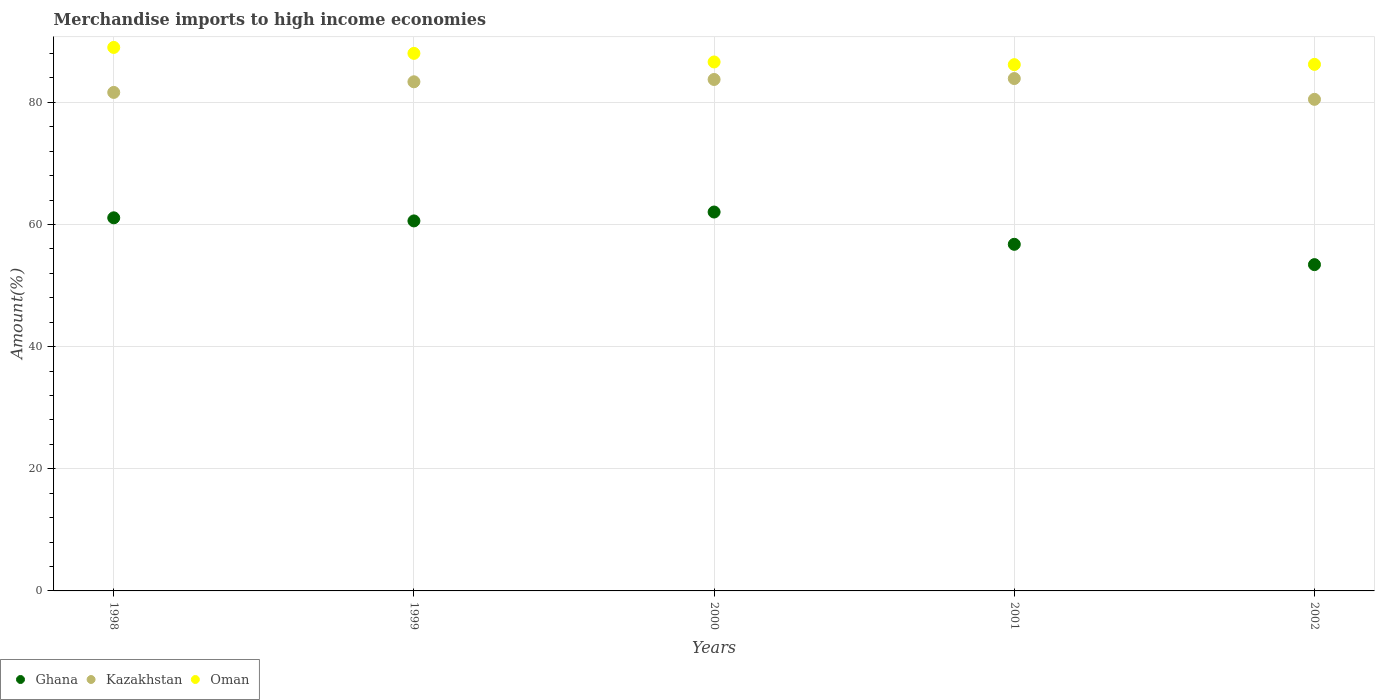Is the number of dotlines equal to the number of legend labels?
Your response must be concise. Yes. What is the percentage of amount earned from merchandise imports in Kazakhstan in 1999?
Offer a terse response. 83.37. Across all years, what is the maximum percentage of amount earned from merchandise imports in Oman?
Offer a very short reply. 89. Across all years, what is the minimum percentage of amount earned from merchandise imports in Ghana?
Give a very brief answer. 53.43. In which year was the percentage of amount earned from merchandise imports in Oman minimum?
Your response must be concise. 2001. What is the total percentage of amount earned from merchandise imports in Ghana in the graph?
Your answer should be very brief. 293.93. What is the difference between the percentage of amount earned from merchandise imports in Ghana in 2000 and that in 2001?
Offer a very short reply. 5.29. What is the difference between the percentage of amount earned from merchandise imports in Ghana in 2002 and the percentage of amount earned from merchandise imports in Kazakhstan in 1999?
Offer a terse response. -29.94. What is the average percentage of amount earned from merchandise imports in Oman per year?
Give a very brief answer. 87.21. In the year 2001, what is the difference between the percentage of amount earned from merchandise imports in Kazakhstan and percentage of amount earned from merchandise imports in Oman?
Give a very brief answer. -2.27. In how many years, is the percentage of amount earned from merchandise imports in Ghana greater than 44 %?
Provide a succinct answer. 5. What is the ratio of the percentage of amount earned from merchandise imports in Kazakhstan in 1999 to that in 2000?
Give a very brief answer. 1. Is the percentage of amount earned from merchandise imports in Ghana in 1998 less than that in 2001?
Give a very brief answer. No. Is the difference between the percentage of amount earned from merchandise imports in Kazakhstan in 1998 and 2002 greater than the difference between the percentage of amount earned from merchandise imports in Oman in 1998 and 2002?
Provide a succinct answer. No. What is the difference between the highest and the second highest percentage of amount earned from merchandise imports in Ghana?
Ensure brevity in your answer.  0.95. What is the difference between the highest and the lowest percentage of amount earned from merchandise imports in Ghana?
Offer a very short reply. 8.61. Is the sum of the percentage of amount earned from merchandise imports in Ghana in 1999 and 2002 greater than the maximum percentage of amount earned from merchandise imports in Oman across all years?
Ensure brevity in your answer.  Yes. Is it the case that in every year, the sum of the percentage of amount earned from merchandise imports in Oman and percentage of amount earned from merchandise imports in Ghana  is greater than the percentage of amount earned from merchandise imports in Kazakhstan?
Give a very brief answer. Yes. Is the percentage of amount earned from merchandise imports in Kazakhstan strictly greater than the percentage of amount earned from merchandise imports in Oman over the years?
Offer a terse response. No. How many dotlines are there?
Provide a short and direct response. 3. Are the values on the major ticks of Y-axis written in scientific E-notation?
Provide a short and direct response. No. How many legend labels are there?
Offer a very short reply. 3. How are the legend labels stacked?
Make the answer very short. Horizontal. What is the title of the graph?
Give a very brief answer. Merchandise imports to high income economies. Does "Morocco" appear as one of the legend labels in the graph?
Give a very brief answer. No. What is the label or title of the X-axis?
Your answer should be very brief. Years. What is the label or title of the Y-axis?
Ensure brevity in your answer.  Amount(%). What is the Amount(%) in Ghana in 1998?
Provide a succinct answer. 61.1. What is the Amount(%) of Kazakhstan in 1998?
Ensure brevity in your answer.  81.63. What is the Amount(%) of Oman in 1998?
Provide a succinct answer. 89. What is the Amount(%) of Ghana in 1999?
Provide a short and direct response. 60.59. What is the Amount(%) of Kazakhstan in 1999?
Keep it short and to the point. 83.37. What is the Amount(%) of Oman in 1999?
Provide a succinct answer. 88.03. What is the Amount(%) of Ghana in 2000?
Make the answer very short. 62.05. What is the Amount(%) of Kazakhstan in 2000?
Your response must be concise. 83.75. What is the Amount(%) of Oman in 2000?
Provide a short and direct response. 86.62. What is the Amount(%) of Ghana in 2001?
Provide a short and direct response. 56.76. What is the Amount(%) in Kazakhstan in 2001?
Make the answer very short. 83.91. What is the Amount(%) of Oman in 2001?
Keep it short and to the point. 86.18. What is the Amount(%) of Ghana in 2002?
Ensure brevity in your answer.  53.43. What is the Amount(%) of Kazakhstan in 2002?
Provide a short and direct response. 80.5. What is the Amount(%) in Oman in 2002?
Make the answer very short. 86.23. Across all years, what is the maximum Amount(%) in Ghana?
Ensure brevity in your answer.  62.05. Across all years, what is the maximum Amount(%) in Kazakhstan?
Offer a terse response. 83.91. Across all years, what is the maximum Amount(%) of Oman?
Give a very brief answer. 89. Across all years, what is the minimum Amount(%) in Ghana?
Your answer should be very brief. 53.43. Across all years, what is the minimum Amount(%) in Kazakhstan?
Provide a succinct answer. 80.5. Across all years, what is the minimum Amount(%) of Oman?
Ensure brevity in your answer.  86.18. What is the total Amount(%) of Ghana in the graph?
Keep it short and to the point. 293.93. What is the total Amount(%) in Kazakhstan in the graph?
Keep it short and to the point. 413.17. What is the total Amount(%) of Oman in the graph?
Offer a terse response. 436.06. What is the difference between the Amount(%) of Ghana in 1998 and that in 1999?
Offer a terse response. 0.51. What is the difference between the Amount(%) in Kazakhstan in 1998 and that in 1999?
Provide a succinct answer. -1.74. What is the difference between the Amount(%) of Oman in 1998 and that in 1999?
Provide a succinct answer. 0.97. What is the difference between the Amount(%) in Ghana in 1998 and that in 2000?
Your response must be concise. -0.95. What is the difference between the Amount(%) of Kazakhstan in 1998 and that in 2000?
Provide a succinct answer. -2.12. What is the difference between the Amount(%) of Oman in 1998 and that in 2000?
Your response must be concise. 2.38. What is the difference between the Amount(%) of Ghana in 1998 and that in 2001?
Offer a very short reply. 4.34. What is the difference between the Amount(%) of Kazakhstan in 1998 and that in 2001?
Your answer should be very brief. -2.27. What is the difference between the Amount(%) of Oman in 1998 and that in 2001?
Your answer should be compact. 2.82. What is the difference between the Amount(%) of Ghana in 1998 and that in 2002?
Ensure brevity in your answer.  7.67. What is the difference between the Amount(%) of Kazakhstan in 1998 and that in 2002?
Offer a very short reply. 1.13. What is the difference between the Amount(%) in Oman in 1998 and that in 2002?
Your response must be concise. 2.77. What is the difference between the Amount(%) in Ghana in 1999 and that in 2000?
Make the answer very short. -1.46. What is the difference between the Amount(%) in Kazakhstan in 1999 and that in 2000?
Provide a succinct answer. -0.38. What is the difference between the Amount(%) of Oman in 1999 and that in 2000?
Offer a very short reply. 1.41. What is the difference between the Amount(%) in Ghana in 1999 and that in 2001?
Your answer should be very brief. 3.83. What is the difference between the Amount(%) in Kazakhstan in 1999 and that in 2001?
Offer a very short reply. -0.53. What is the difference between the Amount(%) in Oman in 1999 and that in 2001?
Give a very brief answer. 1.85. What is the difference between the Amount(%) of Ghana in 1999 and that in 2002?
Keep it short and to the point. 7.16. What is the difference between the Amount(%) in Kazakhstan in 1999 and that in 2002?
Offer a terse response. 2.87. What is the difference between the Amount(%) of Oman in 1999 and that in 2002?
Your response must be concise. 1.8. What is the difference between the Amount(%) of Ghana in 2000 and that in 2001?
Provide a short and direct response. 5.29. What is the difference between the Amount(%) in Kazakhstan in 2000 and that in 2001?
Give a very brief answer. -0.15. What is the difference between the Amount(%) in Oman in 2000 and that in 2001?
Your answer should be very brief. 0.44. What is the difference between the Amount(%) in Ghana in 2000 and that in 2002?
Make the answer very short. 8.61. What is the difference between the Amount(%) in Kazakhstan in 2000 and that in 2002?
Provide a succinct answer. 3.25. What is the difference between the Amount(%) in Oman in 2000 and that in 2002?
Your answer should be very brief. 0.39. What is the difference between the Amount(%) of Ghana in 2001 and that in 2002?
Keep it short and to the point. 3.33. What is the difference between the Amount(%) of Kazakhstan in 2001 and that in 2002?
Your response must be concise. 3.41. What is the difference between the Amount(%) of Oman in 2001 and that in 2002?
Offer a very short reply. -0.05. What is the difference between the Amount(%) of Ghana in 1998 and the Amount(%) of Kazakhstan in 1999?
Provide a succinct answer. -22.28. What is the difference between the Amount(%) of Ghana in 1998 and the Amount(%) of Oman in 1999?
Provide a succinct answer. -26.93. What is the difference between the Amount(%) in Kazakhstan in 1998 and the Amount(%) in Oman in 1999?
Offer a terse response. -6.39. What is the difference between the Amount(%) in Ghana in 1998 and the Amount(%) in Kazakhstan in 2000?
Ensure brevity in your answer.  -22.66. What is the difference between the Amount(%) of Ghana in 1998 and the Amount(%) of Oman in 2000?
Provide a short and direct response. -25.52. What is the difference between the Amount(%) of Kazakhstan in 1998 and the Amount(%) of Oman in 2000?
Make the answer very short. -4.99. What is the difference between the Amount(%) in Ghana in 1998 and the Amount(%) in Kazakhstan in 2001?
Offer a terse response. -22.81. What is the difference between the Amount(%) of Ghana in 1998 and the Amount(%) of Oman in 2001?
Offer a very short reply. -25.08. What is the difference between the Amount(%) in Kazakhstan in 1998 and the Amount(%) in Oman in 2001?
Keep it short and to the point. -4.55. What is the difference between the Amount(%) in Ghana in 1998 and the Amount(%) in Kazakhstan in 2002?
Your answer should be compact. -19.4. What is the difference between the Amount(%) of Ghana in 1998 and the Amount(%) of Oman in 2002?
Your answer should be very brief. -25.13. What is the difference between the Amount(%) of Kazakhstan in 1998 and the Amount(%) of Oman in 2002?
Offer a terse response. -4.59. What is the difference between the Amount(%) of Ghana in 1999 and the Amount(%) of Kazakhstan in 2000?
Provide a short and direct response. -23.16. What is the difference between the Amount(%) in Ghana in 1999 and the Amount(%) in Oman in 2000?
Give a very brief answer. -26.03. What is the difference between the Amount(%) of Kazakhstan in 1999 and the Amount(%) of Oman in 2000?
Offer a terse response. -3.25. What is the difference between the Amount(%) in Ghana in 1999 and the Amount(%) in Kazakhstan in 2001?
Ensure brevity in your answer.  -23.31. What is the difference between the Amount(%) of Ghana in 1999 and the Amount(%) of Oman in 2001?
Offer a terse response. -25.59. What is the difference between the Amount(%) of Kazakhstan in 1999 and the Amount(%) of Oman in 2001?
Your response must be concise. -2.81. What is the difference between the Amount(%) in Ghana in 1999 and the Amount(%) in Kazakhstan in 2002?
Ensure brevity in your answer.  -19.91. What is the difference between the Amount(%) in Ghana in 1999 and the Amount(%) in Oman in 2002?
Your answer should be compact. -25.64. What is the difference between the Amount(%) in Kazakhstan in 1999 and the Amount(%) in Oman in 2002?
Your answer should be compact. -2.85. What is the difference between the Amount(%) in Ghana in 2000 and the Amount(%) in Kazakhstan in 2001?
Offer a very short reply. -21.86. What is the difference between the Amount(%) in Ghana in 2000 and the Amount(%) in Oman in 2001?
Give a very brief answer. -24.13. What is the difference between the Amount(%) of Kazakhstan in 2000 and the Amount(%) of Oman in 2001?
Provide a succinct answer. -2.43. What is the difference between the Amount(%) of Ghana in 2000 and the Amount(%) of Kazakhstan in 2002?
Provide a short and direct response. -18.45. What is the difference between the Amount(%) of Ghana in 2000 and the Amount(%) of Oman in 2002?
Make the answer very short. -24.18. What is the difference between the Amount(%) of Kazakhstan in 2000 and the Amount(%) of Oman in 2002?
Your answer should be very brief. -2.47. What is the difference between the Amount(%) in Ghana in 2001 and the Amount(%) in Kazakhstan in 2002?
Make the answer very short. -23.74. What is the difference between the Amount(%) of Ghana in 2001 and the Amount(%) of Oman in 2002?
Provide a short and direct response. -29.47. What is the difference between the Amount(%) in Kazakhstan in 2001 and the Amount(%) in Oman in 2002?
Your answer should be compact. -2.32. What is the average Amount(%) of Ghana per year?
Your answer should be compact. 58.79. What is the average Amount(%) of Kazakhstan per year?
Your answer should be compact. 82.63. What is the average Amount(%) of Oman per year?
Keep it short and to the point. 87.21. In the year 1998, what is the difference between the Amount(%) in Ghana and Amount(%) in Kazakhstan?
Your answer should be compact. -20.54. In the year 1998, what is the difference between the Amount(%) in Ghana and Amount(%) in Oman?
Ensure brevity in your answer.  -27.9. In the year 1998, what is the difference between the Amount(%) in Kazakhstan and Amount(%) in Oman?
Keep it short and to the point. -7.37. In the year 1999, what is the difference between the Amount(%) of Ghana and Amount(%) of Kazakhstan?
Your answer should be very brief. -22.78. In the year 1999, what is the difference between the Amount(%) of Ghana and Amount(%) of Oman?
Your response must be concise. -27.44. In the year 1999, what is the difference between the Amount(%) in Kazakhstan and Amount(%) in Oman?
Your response must be concise. -4.65. In the year 2000, what is the difference between the Amount(%) in Ghana and Amount(%) in Kazakhstan?
Keep it short and to the point. -21.71. In the year 2000, what is the difference between the Amount(%) in Ghana and Amount(%) in Oman?
Provide a succinct answer. -24.57. In the year 2000, what is the difference between the Amount(%) of Kazakhstan and Amount(%) of Oman?
Provide a short and direct response. -2.87. In the year 2001, what is the difference between the Amount(%) in Ghana and Amount(%) in Kazakhstan?
Make the answer very short. -27.14. In the year 2001, what is the difference between the Amount(%) in Ghana and Amount(%) in Oman?
Your answer should be compact. -29.42. In the year 2001, what is the difference between the Amount(%) of Kazakhstan and Amount(%) of Oman?
Your response must be concise. -2.27. In the year 2002, what is the difference between the Amount(%) in Ghana and Amount(%) in Kazakhstan?
Offer a terse response. -27.07. In the year 2002, what is the difference between the Amount(%) of Ghana and Amount(%) of Oman?
Provide a short and direct response. -32.79. In the year 2002, what is the difference between the Amount(%) of Kazakhstan and Amount(%) of Oman?
Offer a terse response. -5.73. What is the ratio of the Amount(%) of Ghana in 1998 to that in 1999?
Provide a short and direct response. 1.01. What is the ratio of the Amount(%) in Kazakhstan in 1998 to that in 1999?
Offer a very short reply. 0.98. What is the ratio of the Amount(%) in Oman in 1998 to that in 1999?
Your answer should be compact. 1.01. What is the ratio of the Amount(%) of Ghana in 1998 to that in 2000?
Your answer should be very brief. 0.98. What is the ratio of the Amount(%) of Kazakhstan in 1998 to that in 2000?
Your answer should be very brief. 0.97. What is the ratio of the Amount(%) in Oman in 1998 to that in 2000?
Your response must be concise. 1.03. What is the ratio of the Amount(%) of Ghana in 1998 to that in 2001?
Provide a succinct answer. 1.08. What is the ratio of the Amount(%) of Kazakhstan in 1998 to that in 2001?
Offer a very short reply. 0.97. What is the ratio of the Amount(%) of Oman in 1998 to that in 2001?
Your answer should be compact. 1.03. What is the ratio of the Amount(%) of Ghana in 1998 to that in 2002?
Offer a terse response. 1.14. What is the ratio of the Amount(%) in Kazakhstan in 1998 to that in 2002?
Your response must be concise. 1.01. What is the ratio of the Amount(%) in Oman in 1998 to that in 2002?
Offer a terse response. 1.03. What is the ratio of the Amount(%) of Ghana in 1999 to that in 2000?
Ensure brevity in your answer.  0.98. What is the ratio of the Amount(%) in Oman in 1999 to that in 2000?
Keep it short and to the point. 1.02. What is the ratio of the Amount(%) in Ghana in 1999 to that in 2001?
Make the answer very short. 1.07. What is the ratio of the Amount(%) in Kazakhstan in 1999 to that in 2001?
Provide a short and direct response. 0.99. What is the ratio of the Amount(%) in Oman in 1999 to that in 2001?
Provide a short and direct response. 1.02. What is the ratio of the Amount(%) in Ghana in 1999 to that in 2002?
Make the answer very short. 1.13. What is the ratio of the Amount(%) in Kazakhstan in 1999 to that in 2002?
Offer a terse response. 1.04. What is the ratio of the Amount(%) in Oman in 1999 to that in 2002?
Give a very brief answer. 1.02. What is the ratio of the Amount(%) in Ghana in 2000 to that in 2001?
Your response must be concise. 1.09. What is the ratio of the Amount(%) of Oman in 2000 to that in 2001?
Keep it short and to the point. 1.01. What is the ratio of the Amount(%) of Ghana in 2000 to that in 2002?
Make the answer very short. 1.16. What is the ratio of the Amount(%) of Kazakhstan in 2000 to that in 2002?
Your answer should be compact. 1.04. What is the ratio of the Amount(%) in Ghana in 2001 to that in 2002?
Provide a succinct answer. 1.06. What is the ratio of the Amount(%) of Kazakhstan in 2001 to that in 2002?
Provide a short and direct response. 1.04. What is the ratio of the Amount(%) of Oman in 2001 to that in 2002?
Provide a short and direct response. 1. What is the difference between the highest and the second highest Amount(%) of Ghana?
Keep it short and to the point. 0.95. What is the difference between the highest and the second highest Amount(%) of Kazakhstan?
Your answer should be compact. 0.15. What is the difference between the highest and the second highest Amount(%) in Oman?
Ensure brevity in your answer.  0.97. What is the difference between the highest and the lowest Amount(%) in Ghana?
Provide a short and direct response. 8.61. What is the difference between the highest and the lowest Amount(%) of Kazakhstan?
Offer a very short reply. 3.41. What is the difference between the highest and the lowest Amount(%) of Oman?
Offer a very short reply. 2.82. 